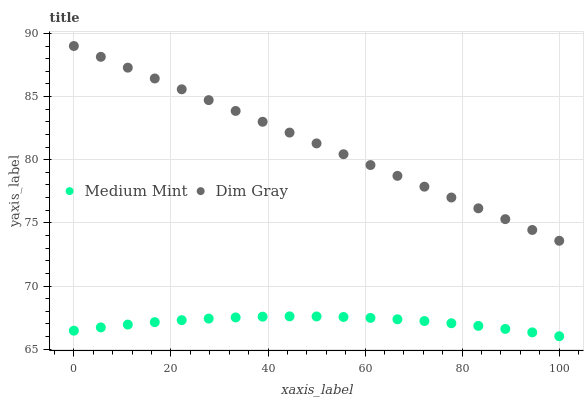Does Medium Mint have the minimum area under the curve?
Answer yes or no. Yes. Does Dim Gray have the maximum area under the curve?
Answer yes or no. Yes. Does Dim Gray have the minimum area under the curve?
Answer yes or no. No. Is Dim Gray the smoothest?
Answer yes or no. Yes. Is Medium Mint the roughest?
Answer yes or no. Yes. Is Dim Gray the roughest?
Answer yes or no. No. Does Medium Mint have the lowest value?
Answer yes or no. Yes. Does Dim Gray have the lowest value?
Answer yes or no. No. Does Dim Gray have the highest value?
Answer yes or no. Yes. Is Medium Mint less than Dim Gray?
Answer yes or no. Yes. Is Dim Gray greater than Medium Mint?
Answer yes or no. Yes. Does Medium Mint intersect Dim Gray?
Answer yes or no. No. 